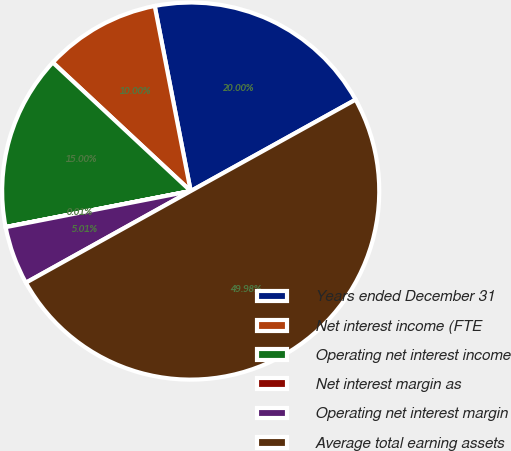Convert chart. <chart><loc_0><loc_0><loc_500><loc_500><pie_chart><fcel>Years ended December 31<fcel>Net interest income (FTE<fcel>Operating net interest income<fcel>Net interest margin as<fcel>Operating net interest margin<fcel>Average total earning assets<nl><fcel>20.0%<fcel>10.0%<fcel>15.0%<fcel>0.01%<fcel>5.01%<fcel>49.98%<nl></chart> 